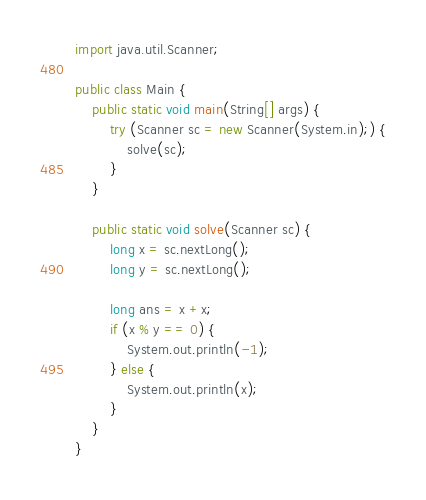Convert code to text. <code><loc_0><loc_0><loc_500><loc_500><_Java_>import java.util.Scanner;

public class Main {
    public static void main(String[] args) {
        try (Scanner sc = new Scanner(System.in);) {
            solve(sc);
        }
    }

    public static void solve(Scanner sc) {
        long x = sc.nextLong();
        long y = sc.nextLong();

        long ans = x +x;
        if (x % y == 0) {
            System.out.println(-1);
        } else {
            System.out.println(x);
        }
    }
}</code> 